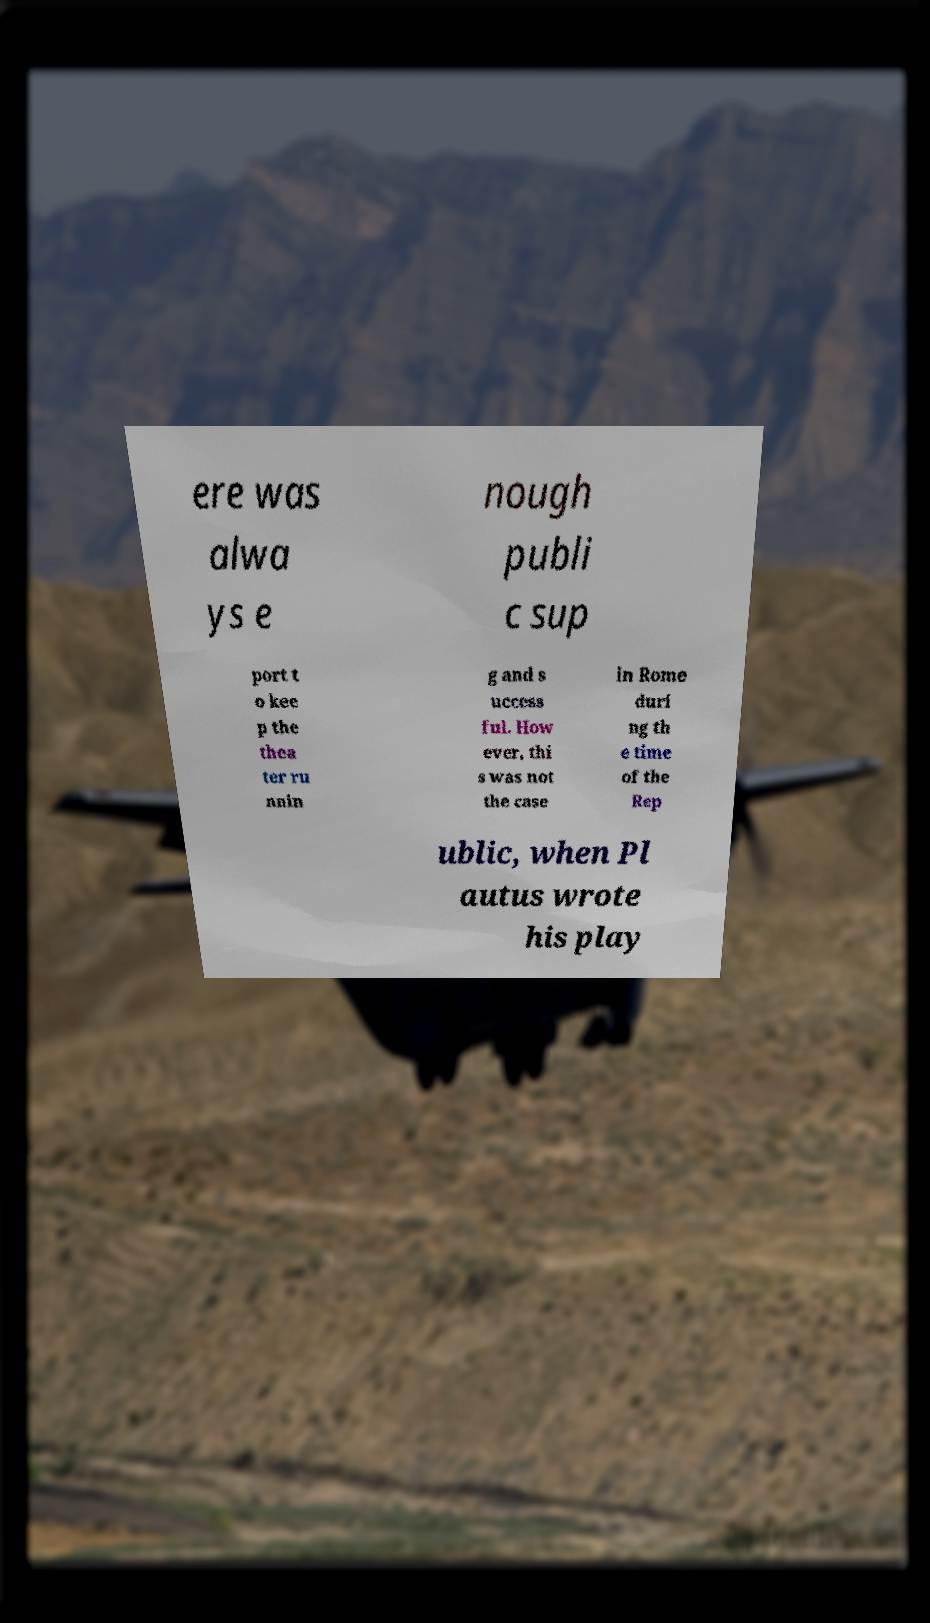There's text embedded in this image that I need extracted. Can you transcribe it verbatim? ere was alwa ys e nough publi c sup port t o kee p the thea ter ru nnin g and s uccess ful. How ever, thi s was not the case in Rome duri ng th e time of the Rep ublic, when Pl autus wrote his play 